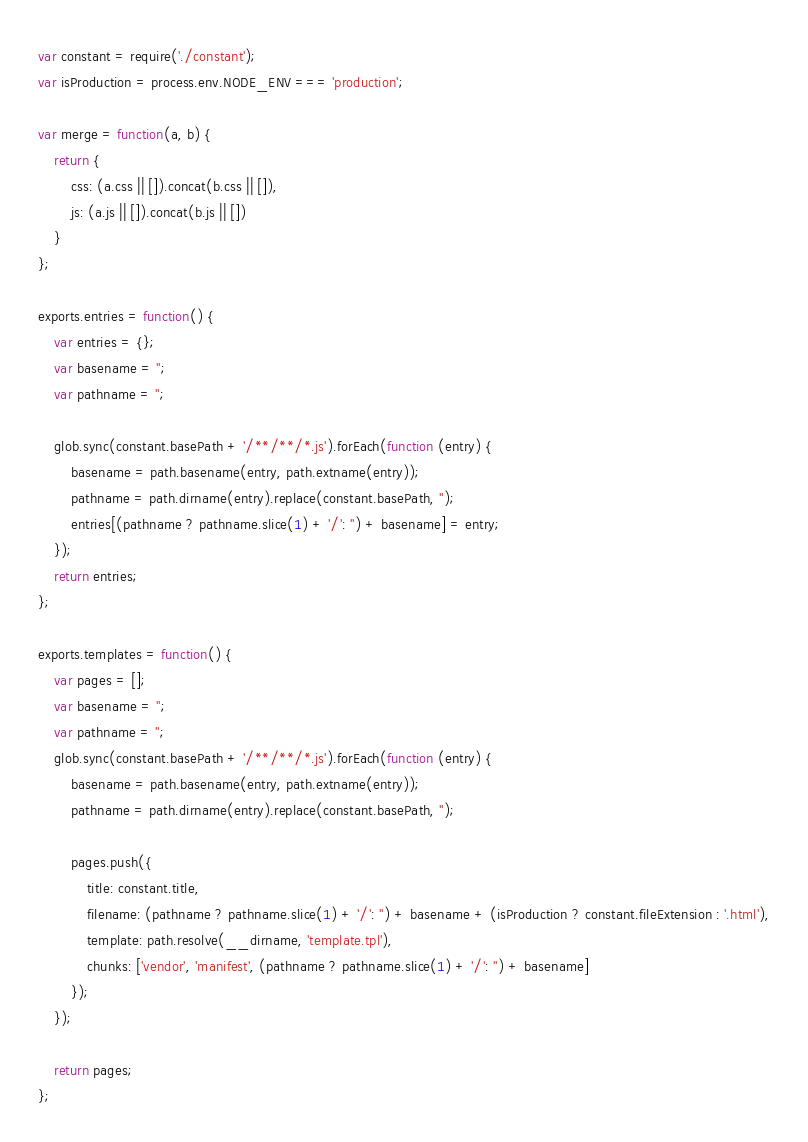<code> <loc_0><loc_0><loc_500><loc_500><_JavaScript_>var constant = require('./constant');
var isProduction = process.env.NODE_ENV === 'production';

var merge = function(a, b) {
    return {
        css: (a.css || []).concat(b.css || []),
        js: (a.js || []).concat(b.js || [])
    }
};

exports.entries = function() {
    var entries = {};
    var basename = '';
    var pathname = '';

    glob.sync(constant.basePath + '/**/**/*.js').forEach(function (entry) {
        basename = path.basename(entry, path.extname(entry));
        pathname = path.dirname(entry).replace(constant.basePath, '');
        entries[(pathname ? pathname.slice(1) + '/': '') + basename] = entry;
    });
    return entries;
};

exports.templates = function() {
    var pages = [];
    var basename = '';
    var pathname = '';
    glob.sync(constant.basePath + '/**/**/*.js').forEach(function (entry) {
        basename = path.basename(entry, path.extname(entry));
        pathname = path.dirname(entry).replace(constant.basePath, '');

        pages.push({
            title: constant.title,
            filename: (pathname ? pathname.slice(1) + '/': '') + basename + (isProduction ? constant.fileExtension : '.html'),
            template: path.resolve(__dirname, 'template.tpl'),
            chunks: ['vendor', 'manifest', (pathname ? pathname.slice(1) + '/': '') + basename]
        });
    });

    return pages;
};</code> 